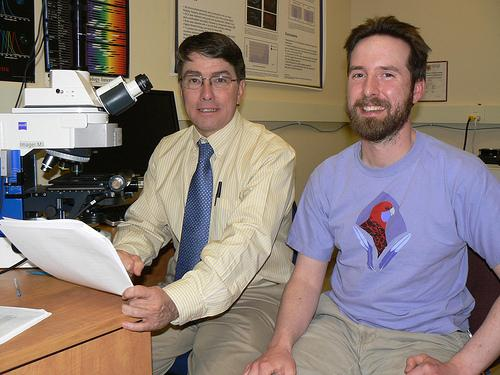Give a brief description of the attire of the man in the yellow shirt. A man wearing a yellow long sleeve button-up shirt, blue tie, and khaki pants, accessorized with metal framed glasses. Identify any items in the image that are typically found in scientific settings and explain their purpose(s). Scientific microscope and computer monitor, commonly used in research for magnification and observation, as well as data analysis and display. What is the key characteristic of the two main subjects in the image? Two men with short brown hair, possibly scientists, are wearing diverse attire and smiling. Describe the interaction between the two men in the image. It seems that one man is holding papers and showing them to the other, both men are sitting down and smiling. How many men are in the image and do they give off a professional vibe based on their attire? Two men are in the image and their attire, including a dress shirt, tie, and pants, suggests that they have a professional vibe. Mention one interesting detail about the man in the light blue t-shirt. The light blue t-shirt has a unique red and black bird design on it. Identify the type of instrument in the image and describe its colors. A scientific microscope with white and black elements. What common facial feature do the two men in the image have? Both men have short brown hair. Enumerate all the types of clothing items present in the image and provide their colors. Yellow long sleeve button-up shirt, light blue t-shirt with bird, purple shirt with red bird, blue tie, light tan pants, khaki pants, shiny blue men's tie. What are the two most distinctive features of the man with glasses in a yellow shirt? Wearing a yellow long-sleeved shirt and metal-framed glasses. Can you see a goldfish swimming in a bowl in the image? No, it's not mentioned in the image. Does the man with glasses have a scar on his left cheek? The only information about the man with glasses pertains to his attire and the fact that he's wearing glasses. There's no mention of any facial features like scars. What item can be found in the man's long sleeve shirt pocket? A black pen Select the correct pair of objects that are found together: A. Yellow shirt and blue pen B. Yellow shirt and blue tie C. Blue tie and red bird on the shirt D. Yellow shirt and black ink pen Yellow shirt and blue tie Choose the correct attributes for the man wearing glasses: A. Man with red beard B. Man with yellow shirt C. Man with a bird on his shirt D. Man with light brown hair Man with light brown hair What type of tie is the blue tie in the image? Shiny What object can be seen with X:7 Y:273 coordinates and provide its color? Blue ink pen Identify an object in use in the scene. The papers in the men's hands Identify the facial hair style of the man with a beard. Short beard with mustache What type of object is seen in the background with a white and black color scheme? Scientific microscope State the kind of shirt the man with facial hair is wearing. Light purple shirt Which man is wearing a long sleeve button up shirt? The man in the yellow shirt What is the relation between the man with glasses and the yellow shirt? The man with glasses is wearing the yellow shirt What object can be found at X:469 Y:105? Electrical outlet Identify and describe an emotion seen on one of the men's faces. They are smiling Estimate the age group of one of the men in the scene. Middle-aged man Identify the color of the shirt with a bird design on it. Light blue Describe the activity taking place in the scene involving the two men. Two men holding papers and discussing, might be scientists What creature is depicted on the purple shirt? Red and black bird What object can be seen at the top of a pen? Pen clip in a shirt pocket Describe the color selection for the outfits for the two possible scientists. One has a yellow shirt and blue tie, the other has a light blue shirt with a red bird on it Is the microscope in the image pink and tiny? The microscope is actually "scientific" and "white and black" in color, which suggests that it is neither pink nor tiny. 